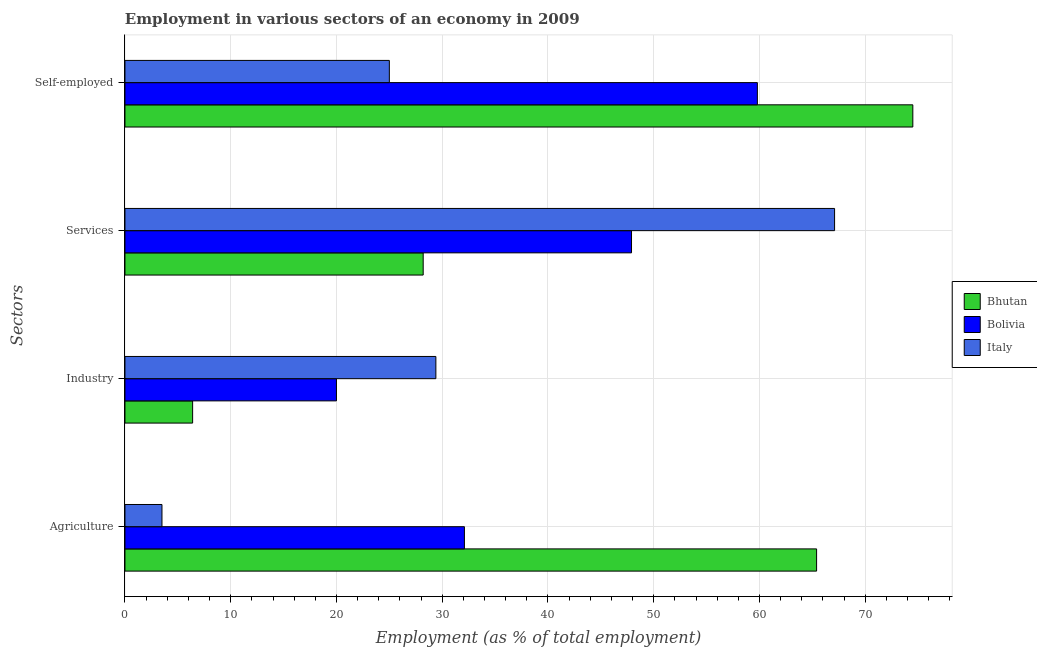How many different coloured bars are there?
Give a very brief answer. 3. What is the label of the 3rd group of bars from the top?
Give a very brief answer. Industry. What is the percentage of self employed workers in Bhutan?
Give a very brief answer. 74.5. Across all countries, what is the maximum percentage of workers in agriculture?
Your answer should be compact. 65.4. Across all countries, what is the minimum percentage of self employed workers?
Ensure brevity in your answer.  25. In which country was the percentage of self employed workers maximum?
Give a very brief answer. Bhutan. In which country was the percentage of workers in industry minimum?
Provide a short and direct response. Bhutan. What is the total percentage of workers in industry in the graph?
Offer a terse response. 55.8. What is the difference between the percentage of workers in agriculture in Italy and that in Bhutan?
Provide a succinct answer. -61.9. What is the difference between the percentage of workers in agriculture in Bolivia and the percentage of workers in industry in Italy?
Keep it short and to the point. 2.7. What is the average percentage of self employed workers per country?
Offer a very short reply. 53.1. What is the difference between the percentage of self employed workers and percentage of workers in industry in Italy?
Provide a succinct answer. -4.4. In how many countries, is the percentage of workers in agriculture greater than 72 %?
Offer a terse response. 0. What is the ratio of the percentage of self employed workers in Italy to that in Bolivia?
Ensure brevity in your answer.  0.42. Is the percentage of workers in agriculture in Bhutan less than that in Bolivia?
Keep it short and to the point. No. Is the difference between the percentage of workers in agriculture in Bhutan and Italy greater than the difference between the percentage of workers in services in Bhutan and Italy?
Ensure brevity in your answer.  Yes. What is the difference between the highest and the second highest percentage of workers in services?
Your answer should be very brief. 19.2. What is the difference between the highest and the lowest percentage of self employed workers?
Your answer should be compact. 49.5. Is the sum of the percentage of workers in agriculture in Italy and Bhutan greater than the maximum percentage of self employed workers across all countries?
Offer a very short reply. No. Is it the case that in every country, the sum of the percentage of workers in industry and percentage of workers in services is greater than the sum of percentage of workers in agriculture and percentage of self employed workers?
Provide a succinct answer. No. What does the 2nd bar from the bottom in Industry represents?
Offer a very short reply. Bolivia. Is it the case that in every country, the sum of the percentage of workers in agriculture and percentage of workers in industry is greater than the percentage of workers in services?
Your response must be concise. No. Does the graph contain any zero values?
Provide a short and direct response. No. Does the graph contain grids?
Give a very brief answer. Yes. How many legend labels are there?
Make the answer very short. 3. What is the title of the graph?
Your answer should be very brief. Employment in various sectors of an economy in 2009. Does "Uganda" appear as one of the legend labels in the graph?
Make the answer very short. No. What is the label or title of the X-axis?
Ensure brevity in your answer.  Employment (as % of total employment). What is the label or title of the Y-axis?
Provide a short and direct response. Sectors. What is the Employment (as % of total employment) in Bhutan in Agriculture?
Provide a short and direct response. 65.4. What is the Employment (as % of total employment) of Bolivia in Agriculture?
Provide a succinct answer. 32.1. What is the Employment (as % of total employment) of Bhutan in Industry?
Offer a terse response. 6.4. What is the Employment (as % of total employment) in Italy in Industry?
Your answer should be compact. 29.4. What is the Employment (as % of total employment) in Bhutan in Services?
Provide a short and direct response. 28.2. What is the Employment (as % of total employment) in Bolivia in Services?
Offer a very short reply. 47.9. What is the Employment (as % of total employment) in Italy in Services?
Your answer should be very brief. 67.1. What is the Employment (as % of total employment) of Bhutan in Self-employed?
Your response must be concise. 74.5. What is the Employment (as % of total employment) in Bolivia in Self-employed?
Provide a short and direct response. 59.8. Across all Sectors, what is the maximum Employment (as % of total employment) in Bhutan?
Your answer should be compact. 74.5. Across all Sectors, what is the maximum Employment (as % of total employment) in Bolivia?
Keep it short and to the point. 59.8. Across all Sectors, what is the maximum Employment (as % of total employment) of Italy?
Provide a short and direct response. 67.1. Across all Sectors, what is the minimum Employment (as % of total employment) in Bhutan?
Keep it short and to the point. 6.4. Across all Sectors, what is the minimum Employment (as % of total employment) of Bolivia?
Make the answer very short. 20. Across all Sectors, what is the minimum Employment (as % of total employment) in Italy?
Keep it short and to the point. 3.5. What is the total Employment (as % of total employment) in Bhutan in the graph?
Provide a short and direct response. 174.5. What is the total Employment (as % of total employment) in Bolivia in the graph?
Make the answer very short. 159.8. What is the total Employment (as % of total employment) in Italy in the graph?
Your response must be concise. 125. What is the difference between the Employment (as % of total employment) in Bhutan in Agriculture and that in Industry?
Offer a terse response. 59. What is the difference between the Employment (as % of total employment) in Italy in Agriculture and that in Industry?
Your answer should be compact. -25.9. What is the difference between the Employment (as % of total employment) in Bhutan in Agriculture and that in Services?
Provide a succinct answer. 37.2. What is the difference between the Employment (as % of total employment) of Bolivia in Agriculture and that in Services?
Ensure brevity in your answer.  -15.8. What is the difference between the Employment (as % of total employment) of Italy in Agriculture and that in Services?
Provide a succinct answer. -63.6. What is the difference between the Employment (as % of total employment) of Bhutan in Agriculture and that in Self-employed?
Offer a very short reply. -9.1. What is the difference between the Employment (as % of total employment) in Bolivia in Agriculture and that in Self-employed?
Your response must be concise. -27.7. What is the difference between the Employment (as % of total employment) of Italy in Agriculture and that in Self-employed?
Offer a very short reply. -21.5. What is the difference between the Employment (as % of total employment) in Bhutan in Industry and that in Services?
Your response must be concise. -21.8. What is the difference between the Employment (as % of total employment) in Bolivia in Industry and that in Services?
Make the answer very short. -27.9. What is the difference between the Employment (as % of total employment) in Italy in Industry and that in Services?
Your answer should be compact. -37.7. What is the difference between the Employment (as % of total employment) of Bhutan in Industry and that in Self-employed?
Ensure brevity in your answer.  -68.1. What is the difference between the Employment (as % of total employment) of Bolivia in Industry and that in Self-employed?
Your answer should be very brief. -39.8. What is the difference between the Employment (as % of total employment) in Bhutan in Services and that in Self-employed?
Provide a short and direct response. -46.3. What is the difference between the Employment (as % of total employment) in Italy in Services and that in Self-employed?
Your answer should be very brief. 42.1. What is the difference between the Employment (as % of total employment) in Bhutan in Agriculture and the Employment (as % of total employment) in Bolivia in Industry?
Your answer should be very brief. 45.4. What is the difference between the Employment (as % of total employment) in Bhutan in Agriculture and the Employment (as % of total employment) in Bolivia in Services?
Keep it short and to the point. 17.5. What is the difference between the Employment (as % of total employment) of Bhutan in Agriculture and the Employment (as % of total employment) of Italy in Services?
Your answer should be compact. -1.7. What is the difference between the Employment (as % of total employment) in Bolivia in Agriculture and the Employment (as % of total employment) in Italy in Services?
Give a very brief answer. -35. What is the difference between the Employment (as % of total employment) in Bhutan in Agriculture and the Employment (as % of total employment) in Italy in Self-employed?
Provide a succinct answer. 40.4. What is the difference between the Employment (as % of total employment) of Bolivia in Agriculture and the Employment (as % of total employment) of Italy in Self-employed?
Offer a terse response. 7.1. What is the difference between the Employment (as % of total employment) in Bhutan in Industry and the Employment (as % of total employment) in Bolivia in Services?
Provide a succinct answer. -41.5. What is the difference between the Employment (as % of total employment) of Bhutan in Industry and the Employment (as % of total employment) of Italy in Services?
Give a very brief answer. -60.7. What is the difference between the Employment (as % of total employment) of Bolivia in Industry and the Employment (as % of total employment) of Italy in Services?
Offer a terse response. -47.1. What is the difference between the Employment (as % of total employment) in Bhutan in Industry and the Employment (as % of total employment) in Bolivia in Self-employed?
Provide a short and direct response. -53.4. What is the difference between the Employment (as % of total employment) in Bhutan in Industry and the Employment (as % of total employment) in Italy in Self-employed?
Your answer should be compact. -18.6. What is the difference between the Employment (as % of total employment) of Bolivia in Industry and the Employment (as % of total employment) of Italy in Self-employed?
Give a very brief answer. -5. What is the difference between the Employment (as % of total employment) in Bhutan in Services and the Employment (as % of total employment) in Bolivia in Self-employed?
Offer a terse response. -31.6. What is the difference between the Employment (as % of total employment) in Bhutan in Services and the Employment (as % of total employment) in Italy in Self-employed?
Your answer should be very brief. 3.2. What is the difference between the Employment (as % of total employment) of Bolivia in Services and the Employment (as % of total employment) of Italy in Self-employed?
Your response must be concise. 22.9. What is the average Employment (as % of total employment) in Bhutan per Sectors?
Provide a succinct answer. 43.62. What is the average Employment (as % of total employment) in Bolivia per Sectors?
Your answer should be compact. 39.95. What is the average Employment (as % of total employment) in Italy per Sectors?
Provide a short and direct response. 31.25. What is the difference between the Employment (as % of total employment) in Bhutan and Employment (as % of total employment) in Bolivia in Agriculture?
Provide a short and direct response. 33.3. What is the difference between the Employment (as % of total employment) of Bhutan and Employment (as % of total employment) of Italy in Agriculture?
Provide a short and direct response. 61.9. What is the difference between the Employment (as % of total employment) in Bolivia and Employment (as % of total employment) in Italy in Agriculture?
Give a very brief answer. 28.6. What is the difference between the Employment (as % of total employment) of Bhutan and Employment (as % of total employment) of Bolivia in Services?
Your response must be concise. -19.7. What is the difference between the Employment (as % of total employment) in Bhutan and Employment (as % of total employment) in Italy in Services?
Offer a very short reply. -38.9. What is the difference between the Employment (as % of total employment) of Bolivia and Employment (as % of total employment) of Italy in Services?
Your answer should be very brief. -19.2. What is the difference between the Employment (as % of total employment) of Bhutan and Employment (as % of total employment) of Bolivia in Self-employed?
Your response must be concise. 14.7. What is the difference between the Employment (as % of total employment) in Bhutan and Employment (as % of total employment) in Italy in Self-employed?
Your answer should be very brief. 49.5. What is the difference between the Employment (as % of total employment) of Bolivia and Employment (as % of total employment) of Italy in Self-employed?
Offer a very short reply. 34.8. What is the ratio of the Employment (as % of total employment) in Bhutan in Agriculture to that in Industry?
Ensure brevity in your answer.  10.22. What is the ratio of the Employment (as % of total employment) in Bolivia in Agriculture to that in Industry?
Your answer should be compact. 1.6. What is the ratio of the Employment (as % of total employment) of Italy in Agriculture to that in Industry?
Offer a terse response. 0.12. What is the ratio of the Employment (as % of total employment) of Bhutan in Agriculture to that in Services?
Your answer should be very brief. 2.32. What is the ratio of the Employment (as % of total employment) in Bolivia in Agriculture to that in Services?
Make the answer very short. 0.67. What is the ratio of the Employment (as % of total employment) in Italy in Agriculture to that in Services?
Your answer should be very brief. 0.05. What is the ratio of the Employment (as % of total employment) in Bhutan in Agriculture to that in Self-employed?
Offer a terse response. 0.88. What is the ratio of the Employment (as % of total employment) in Bolivia in Agriculture to that in Self-employed?
Offer a very short reply. 0.54. What is the ratio of the Employment (as % of total employment) in Italy in Agriculture to that in Self-employed?
Provide a succinct answer. 0.14. What is the ratio of the Employment (as % of total employment) in Bhutan in Industry to that in Services?
Provide a short and direct response. 0.23. What is the ratio of the Employment (as % of total employment) in Bolivia in Industry to that in Services?
Ensure brevity in your answer.  0.42. What is the ratio of the Employment (as % of total employment) of Italy in Industry to that in Services?
Provide a succinct answer. 0.44. What is the ratio of the Employment (as % of total employment) of Bhutan in Industry to that in Self-employed?
Your answer should be very brief. 0.09. What is the ratio of the Employment (as % of total employment) of Bolivia in Industry to that in Self-employed?
Ensure brevity in your answer.  0.33. What is the ratio of the Employment (as % of total employment) of Italy in Industry to that in Self-employed?
Give a very brief answer. 1.18. What is the ratio of the Employment (as % of total employment) in Bhutan in Services to that in Self-employed?
Your response must be concise. 0.38. What is the ratio of the Employment (as % of total employment) of Bolivia in Services to that in Self-employed?
Offer a very short reply. 0.8. What is the ratio of the Employment (as % of total employment) in Italy in Services to that in Self-employed?
Give a very brief answer. 2.68. What is the difference between the highest and the second highest Employment (as % of total employment) of Bolivia?
Offer a very short reply. 11.9. What is the difference between the highest and the second highest Employment (as % of total employment) in Italy?
Offer a very short reply. 37.7. What is the difference between the highest and the lowest Employment (as % of total employment) in Bhutan?
Provide a short and direct response. 68.1. What is the difference between the highest and the lowest Employment (as % of total employment) of Bolivia?
Provide a succinct answer. 39.8. What is the difference between the highest and the lowest Employment (as % of total employment) of Italy?
Offer a very short reply. 63.6. 